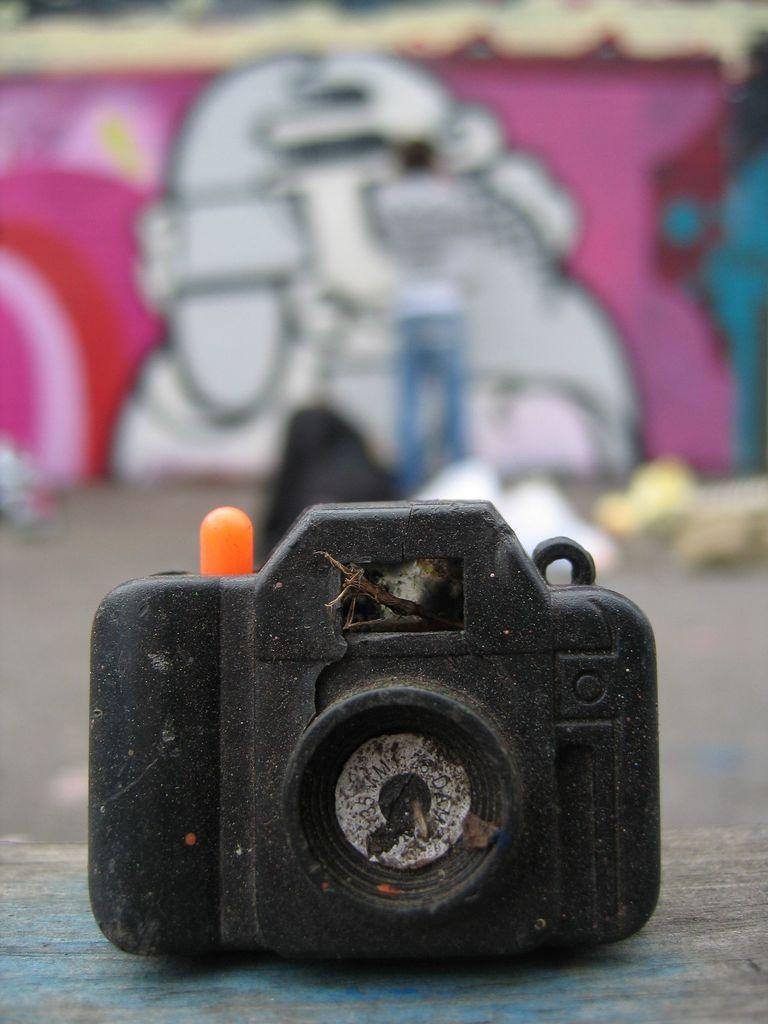What is the main object in the foreground of the image? There is a camera in the foreground of the image. What can be seen in the background of the image? There is a person and a wall in the background of the image. What is on the wall in the background? There is graffiti on the wall. What is at the bottom of the image? There is a walkway at the bottom of the image. What advice does the sock in the image give to the person in the background? There is no sock present in the image, so it cannot provide any advice. 